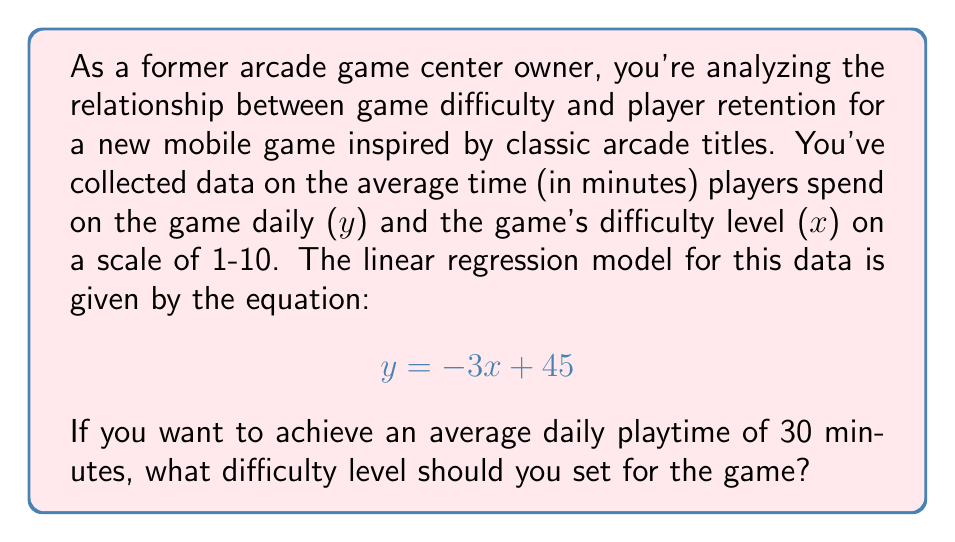Show me your answer to this math problem. To solve this problem, we'll use the given linear equation and follow these steps:

1) The linear equation is in the form $y = mx + b$, where:
   $m = -3$ (slope)
   $b = 45$ (y-intercept)

2) We want to find $x$ (difficulty level) when $y$ (average daily playtime) is 30 minutes.

3) Substitute the known values into the equation:
   $$ 30 = -3x + 45 $$

4) Subtract 45 from both sides:
   $$ -15 = -3x $$

5) Divide both sides by -3:
   $$ 5 = x $$

6) Check the result:
   If $x = 5$, then $y = -3(5) + 45 = -15 + 45 = 30$

This difficulty level aligns with the "golden ratio" often used in classic arcade games, where the game is challenging enough to keep players engaged but not so difficult that they give up quickly.
Answer: The game's difficulty level should be set to 5 to achieve an average daily playtime of 30 minutes. 